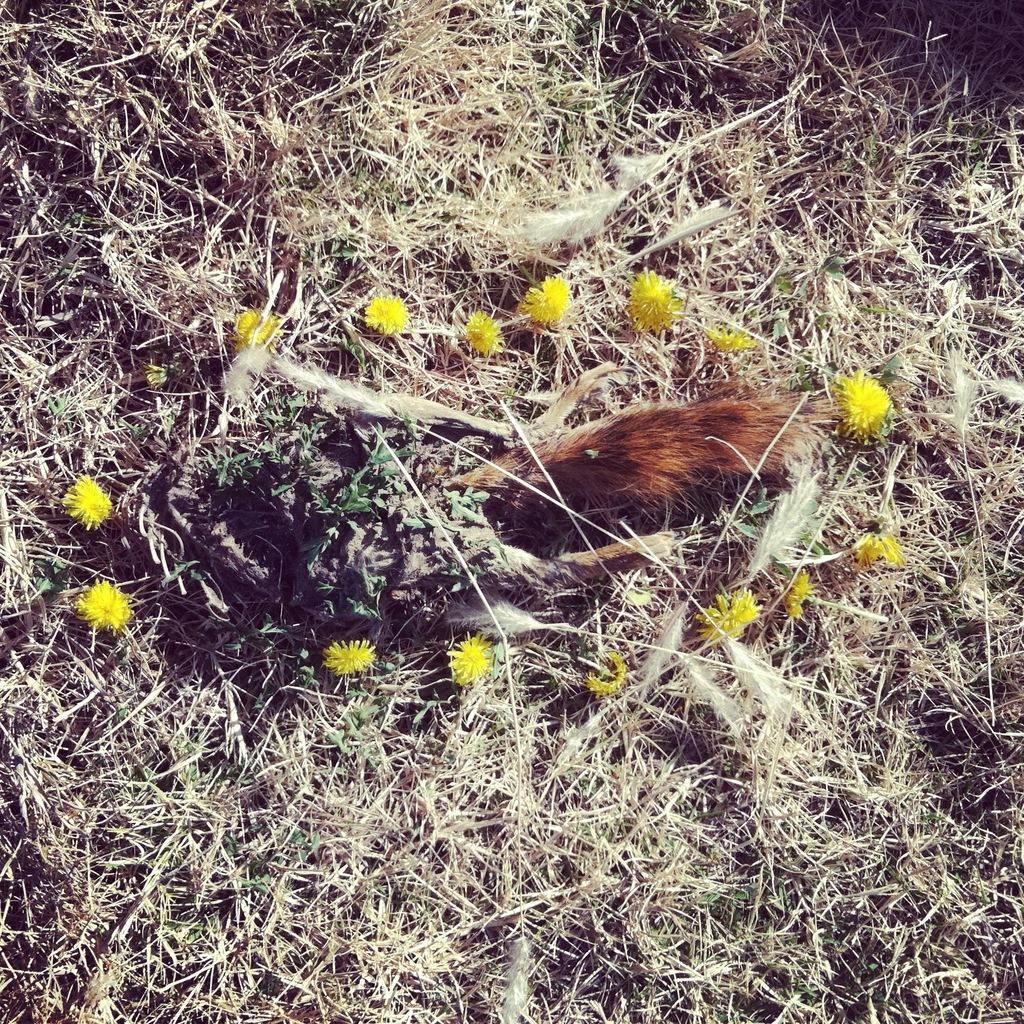What type of animal is in the foreground of the image? There is an animal in the foreground of the image, but the specific type cannot be determined from the provided facts. Where is the animal located in relation to the ground? The animal is on the land in the image. What type of vegetation can be seen in the image? Flowers and dried grass are visible in the image. What type of pen is the animal holding in the image? There is no pen present in the image; the animal is on the land and surrounded by flowers and dried grass. 